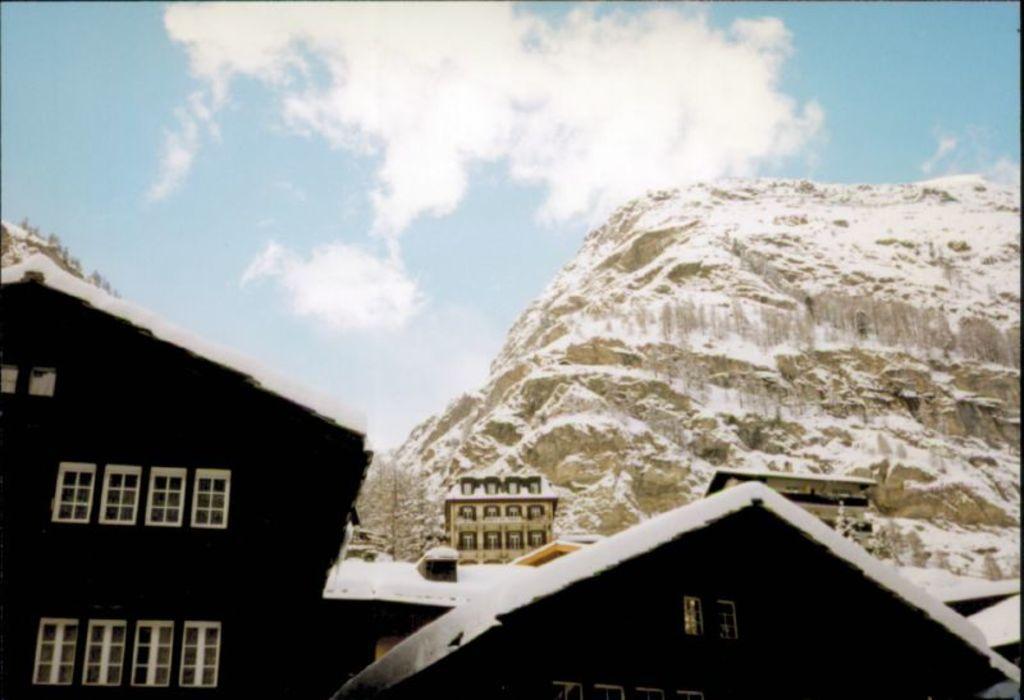Please provide a concise description of this image. In this image I can see a house and a tree. In the background I can see a mountain and clear sky. 